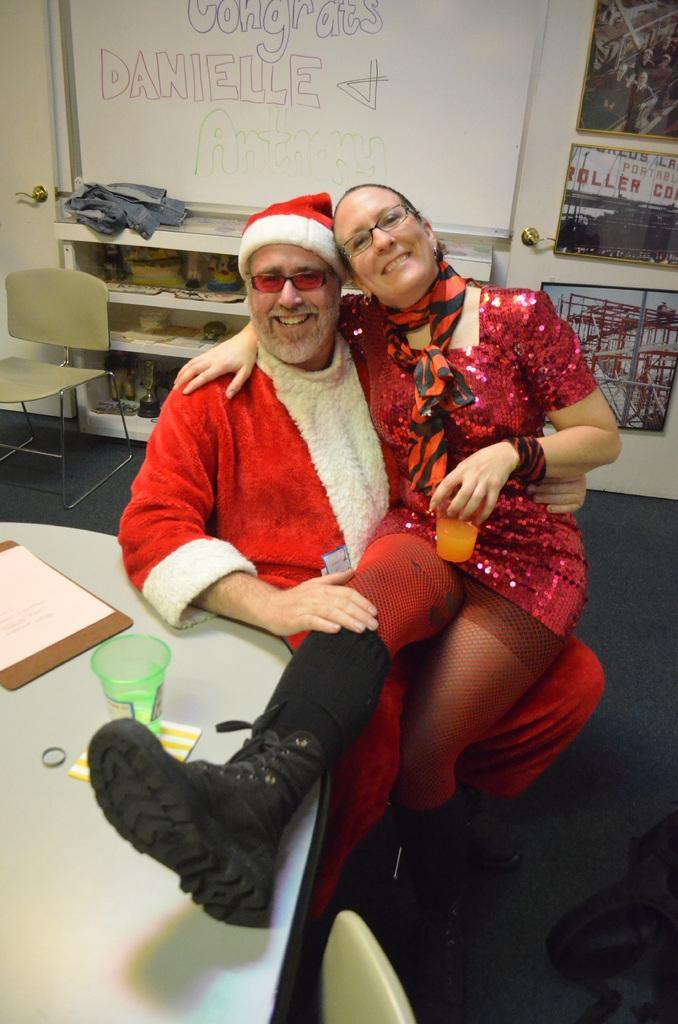In one or two sentences, can you explain what this image depicts? In this image we can see two persons sitting and smiling, among them one person is holding a glass, there is a table, on the table, we can see a glass, paper and other objects, in the background we can see some shelves with objects, there are some photo frames and a board on the wall. 